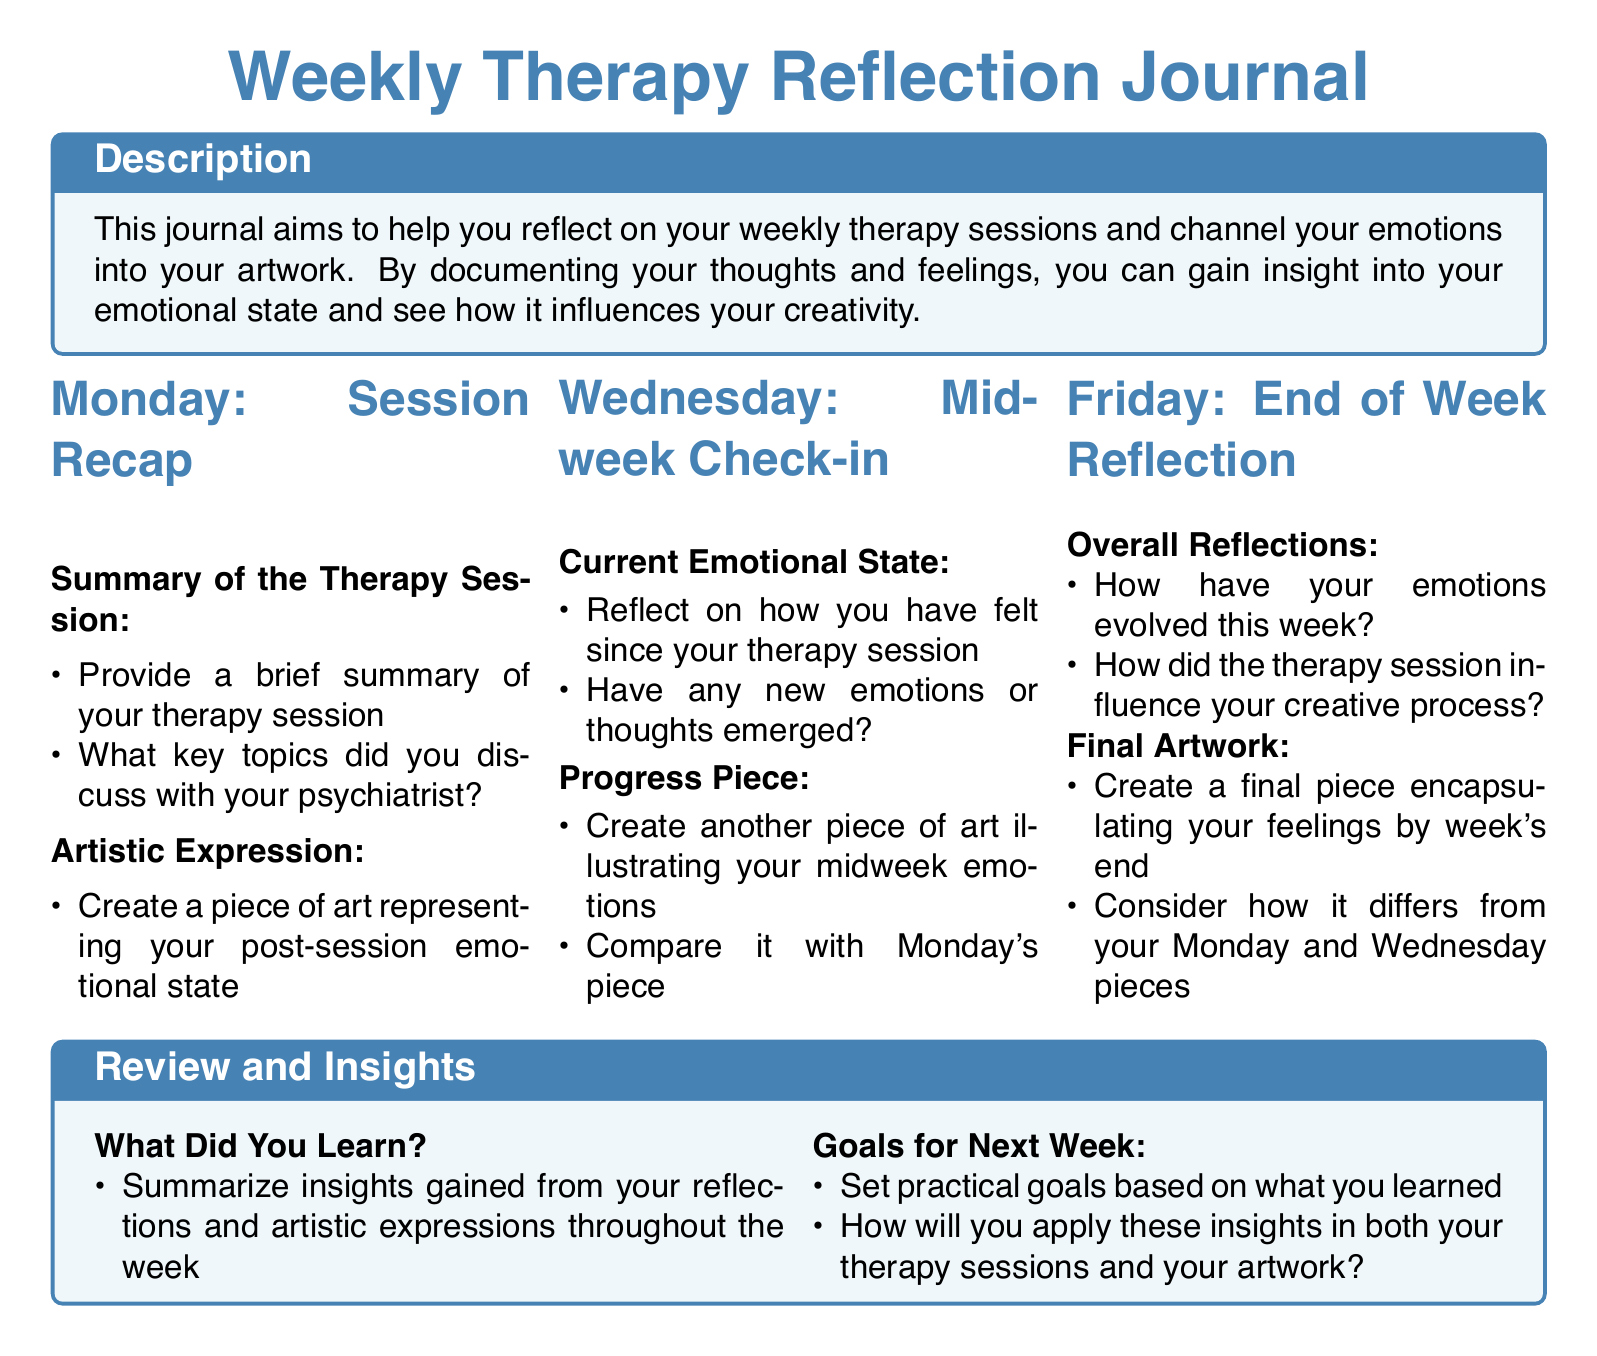What is the title of the journal? The title is clearly stated at the beginning of the document, which is "Weekly Therapy Reflection Journal".
Answer: Weekly Therapy Reflection Journal How many sections are there in the document? The document is structured with three main sections corresponding to different days of the week.
Answer: Three What color is used for the section titles? The document specifies the color used for section titles, which is artistblue.
Answer: artistblue What day is associated with the initial session recap? The schedule highlights the specific day for the session recap, which is Monday.
Answer: Monday What is the primary purpose of the journal? The purpose of the journal is described in the document, focusing on emotional reflection and artistic expression.
Answer: Reflect on weekly therapy sessions How should emotions be expressed artistically on Wednesday? The document instructs to create another piece of art illustrating midweek emotions and to compare it with Monday's piece.
Answer: Create another piece of art What do participants need to summarize at the end of the week? The document asks participants to summarize insights gained from their reflections and artistic expressions throughout the week.
Answer: Insights gained What type of goals should be set for the next week? The document suggests setting practical goals based on what was learned during the reflections of the week.
Answer: Practical goals What is the last task to complete at the end of the week? The final task mentioned in the document is to create a final piece encapsulating feelings by week's end.
Answer: Create a final piece 